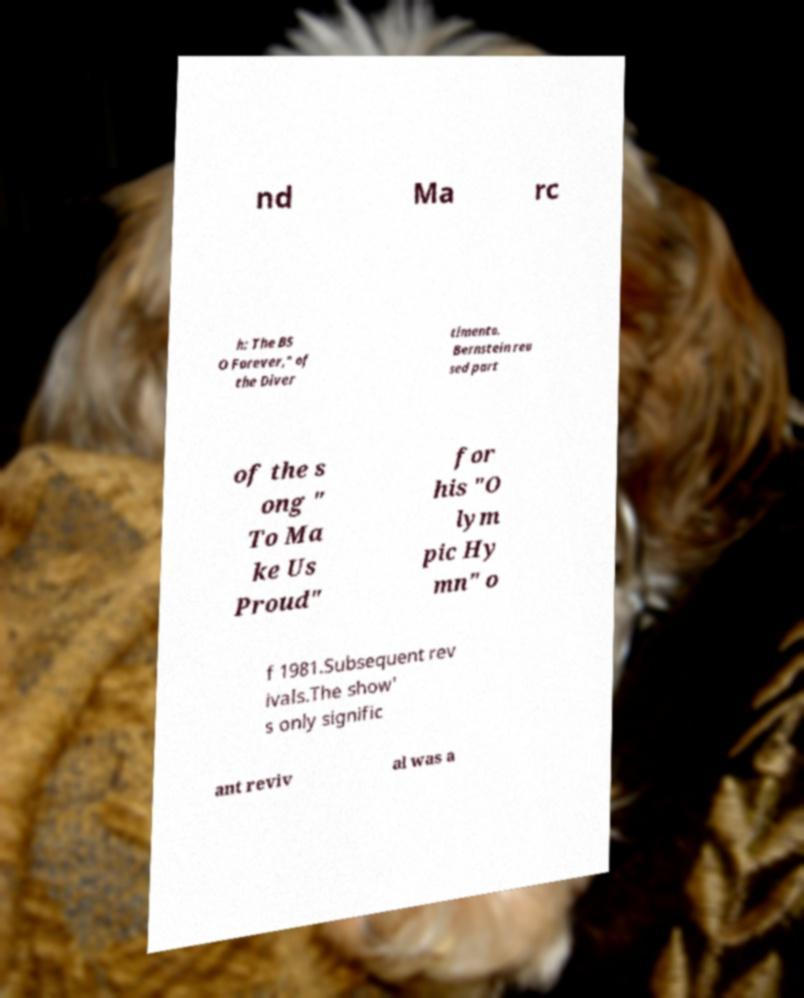Please read and relay the text visible in this image. What does it say? nd Ma rc h: The BS O Forever," of the Diver timento. Bernstein reu sed part of the s ong " To Ma ke Us Proud" for his "O lym pic Hy mn" o f 1981.Subsequent rev ivals.The show' s only signific ant reviv al was a 